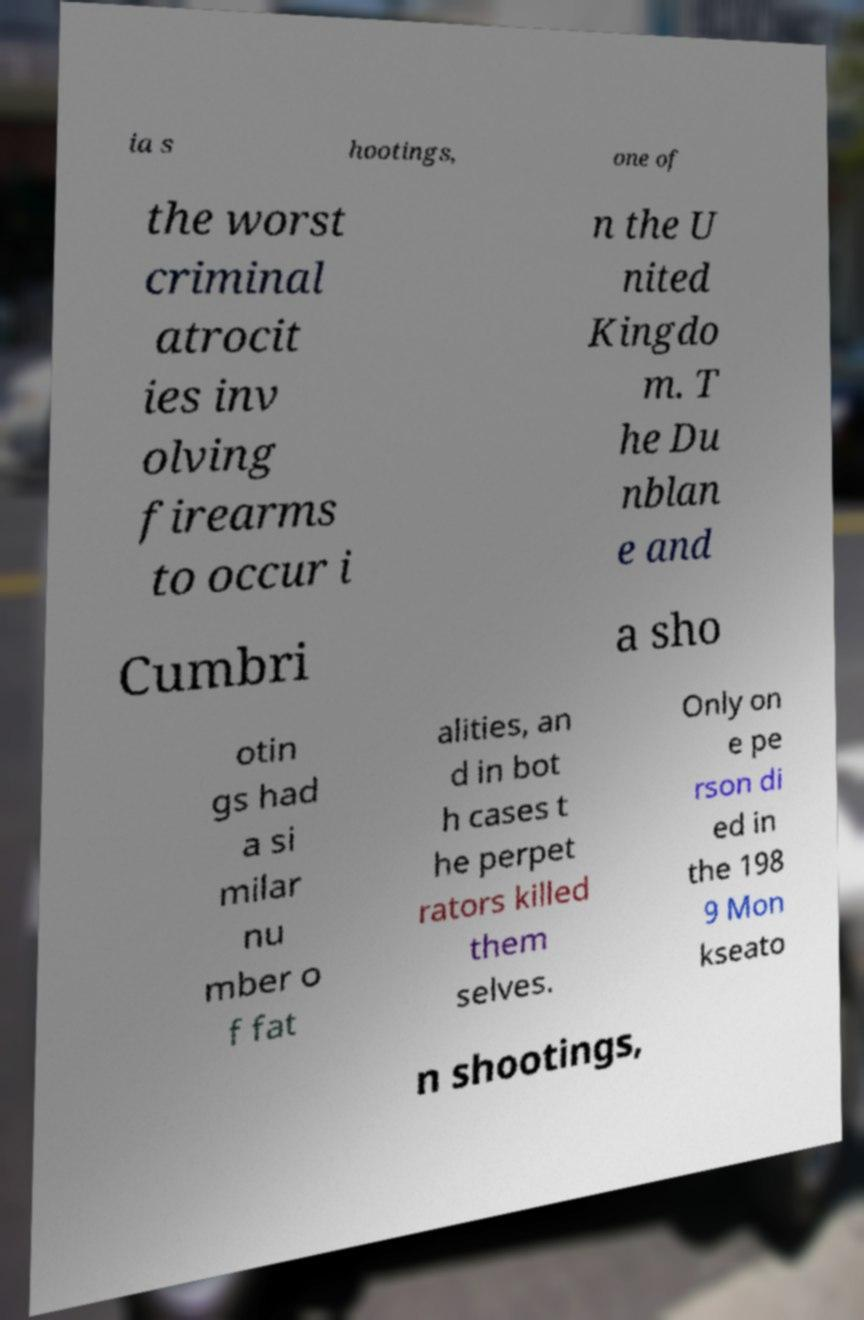I need the written content from this picture converted into text. Can you do that? ia s hootings, one of the worst criminal atrocit ies inv olving firearms to occur i n the U nited Kingdo m. T he Du nblan e and Cumbri a sho otin gs had a si milar nu mber o f fat alities, an d in bot h cases t he perpet rators killed them selves. Only on e pe rson di ed in the 198 9 Mon kseato n shootings, 